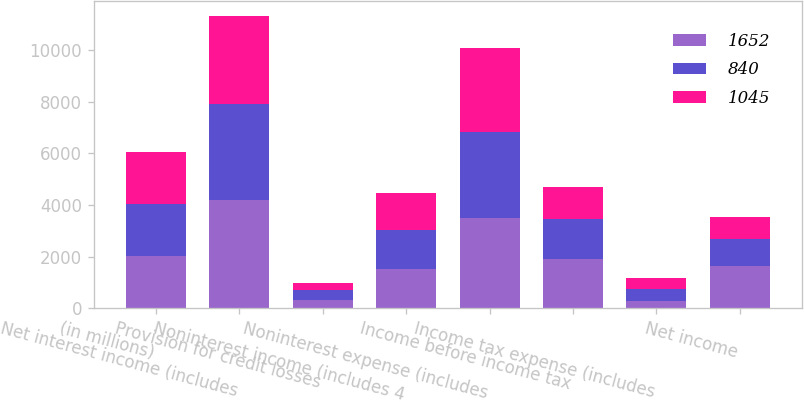Convert chart. <chart><loc_0><loc_0><loc_500><loc_500><stacked_bar_chart><ecel><fcel>(in millions)<fcel>Net interest income (includes<fcel>Provision for credit losses<fcel>Noninterest income (includes 4<fcel>Noninterest expense (includes<fcel>Income before income tax<fcel>Income tax expense (includes<fcel>Net income<nl><fcel>1652<fcel>2017<fcel>4173<fcel>321<fcel>1534<fcel>3474<fcel>1912<fcel>260<fcel>1652<nl><fcel>840<fcel>2016<fcel>3758<fcel>369<fcel>1497<fcel>3352<fcel>1534<fcel>489<fcel>1045<nl><fcel>1045<fcel>2015<fcel>3402<fcel>302<fcel>1422<fcel>3259<fcel>1263<fcel>423<fcel>840<nl></chart> 